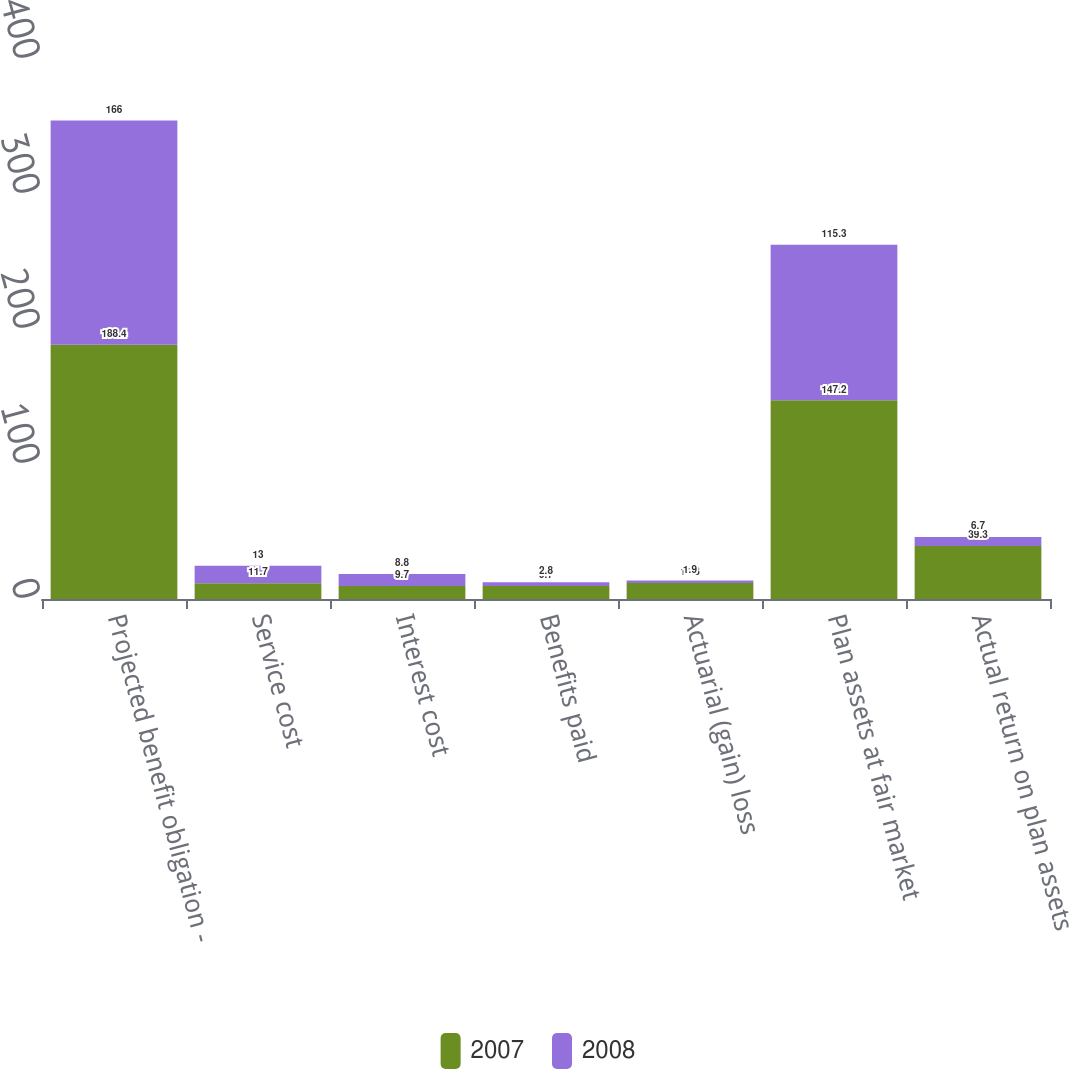<chart> <loc_0><loc_0><loc_500><loc_500><stacked_bar_chart><ecel><fcel>Projected benefit obligation -<fcel>Service cost<fcel>Interest cost<fcel>Benefits paid<fcel>Actuarial (gain) loss<fcel>Plan assets at fair market<fcel>Actual return on plan assets<nl><fcel>2007<fcel>188.4<fcel>11.7<fcel>9.7<fcel>9.7<fcel>11.8<fcel>147.2<fcel>39.3<nl><fcel>2008<fcel>166<fcel>13<fcel>8.8<fcel>2.8<fcel>1.9<fcel>115.3<fcel>6.7<nl></chart> 